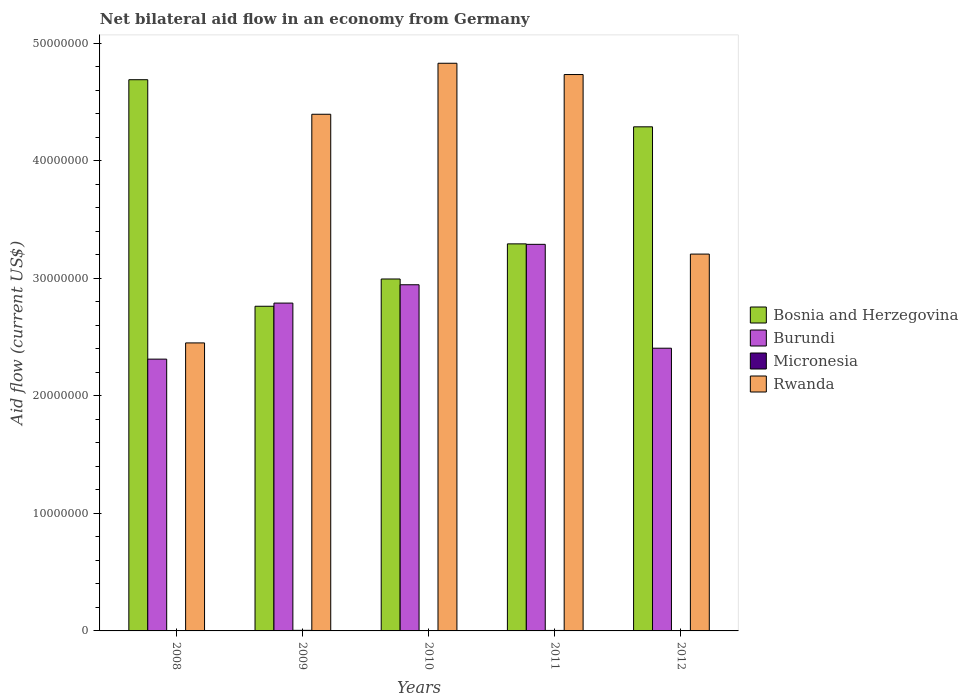How many different coloured bars are there?
Offer a very short reply. 4. Are the number of bars on each tick of the X-axis equal?
Make the answer very short. Yes. What is the net bilateral aid flow in Micronesia in 2008?
Give a very brief answer. 3.00e+04. Across all years, what is the maximum net bilateral aid flow in Burundi?
Provide a succinct answer. 3.29e+07. Across all years, what is the minimum net bilateral aid flow in Burundi?
Offer a very short reply. 2.31e+07. What is the total net bilateral aid flow in Burundi in the graph?
Provide a short and direct response. 1.37e+08. What is the difference between the net bilateral aid flow in Rwanda in 2008 and that in 2009?
Offer a terse response. -1.95e+07. What is the difference between the net bilateral aid flow in Rwanda in 2011 and the net bilateral aid flow in Bosnia and Herzegovina in 2012?
Your answer should be very brief. 4.45e+06. What is the average net bilateral aid flow in Burundi per year?
Provide a short and direct response. 2.75e+07. In the year 2009, what is the difference between the net bilateral aid flow in Micronesia and net bilateral aid flow in Rwanda?
Offer a very short reply. -4.39e+07. In how many years, is the net bilateral aid flow in Burundi greater than 42000000 US$?
Ensure brevity in your answer.  0. What is the ratio of the net bilateral aid flow in Burundi in 2009 to that in 2011?
Ensure brevity in your answer.  0.85. Is the difference between the net bilateral aid flow in Micronesia in 2011 and 2012 greater than the difference between the net bilateral aid flow in Rwanda in 2011 and 2012?
Provide a succinct answer. No. What is the difference between the highest and the second highest net bilateral aid flow in Bosnia and Herzegovina?
Offer a terse response. 4.01e+06. What is the difference between the highest and the lowest net bilateral aid flow in Bosnia and Herzegovina?
Offer a terse response. 1.93e+07. In how many years, is the net bilateral aid flow in Rwanda greater than the average net bilateral aid flow in Rwanda taken over all years?
Provide a succinct answer. 3. Is the sum of the net bilateral aid flow in Bosnia and Herzegovina in 2010 and 2011 greater than the maximum net bilateral aid flow in Micronesia across all years?
Make the answer very short. Yes. Is it the case that in every year, the sum of the net bilateral aid flow in Micronesia and net bilateral aid flow in Bosnia and Herzegovina is greater than the sum of net bilateral aid flow in Burundi and net bilateral aid flow in Rwanda?
Make the answer very short. No. What does the 2nd bar from the left in 2008 represents?
Provide a succinct answer. Burundi. What does the 1st bar from the right in 2012 represents?
Offer a terse response. Rwanda. How many years are there in the graph?
Give a very brief answer. 5. Where does the legend appear in the graph?
Your response must be concise. Center right. How many legend labels are there?
Your answer should be very brief. 4. What is the title of the graph?
Your answer should be compact. Net bilateral aid flow in an economy from Germany. What is the label or title of the X-axis?
Give a very brief answer. Years. What is the label or title of the Y-axis?
Offer a very short reply. Aid flow (current US$). What is the Aid flow (current US$) in Bosnia and Herzegovina in 2008?
Keep it short and to the point. 4.69e+07. What is the Aid flow (current US$) of Burundi in 2008?
Keep it short and to the point. 2.31e+07. What is the Aid flow (current US$) of Micronesia in 2008?
Your answer should be compact. 3.00e+04. What is the Aid flow (current US$) in Rwanda in 2008?
Your answer should be very brief. 2.45e+07. What is the Aid flow (current US$) of Bosnia and Herzegovina in 2009?
Your answer should be compact. 2.76e+07. What is the Aid flow (current US$) in Burundi in 2009?
Offer a terse response. 2.79e+07. What is the Aid flow (current US$) of Rwanda in 2009?
Your answer should be very brief. 4.40e+07. What is the Aid flow (current US$) of Bosnia and Herzegovina in 2010?
Your answer should be compact. 3.00e+07. What is the Aid flow (current US$) of Burundi in 2010?
Make the answer very short. 2.95e+07. What is the Aid flow (current US$) in Rwanda in 2010?
Offer a terse response. 4.83e+07. What is the Aid flow (current US$) in Bosnia and Herzegovina in 2011?
Offer a very short reply. 3.29e+07. What is the Aid flow (current US$) of Burundi in 2011?
Offer a very short reply. 3.29e+07. What is the Aid flow (current US$) of Rwanda in 2011?
Give a very brief answer. 4.74e+07. What is the Aid flow (current US$) of Bosnia and Herzegovina in 2012?
Offer a terse response. 4.29e+07. What is the Aid flow (current US$) of Burundi in 2012?
Provide a succinct answer. 2.41e+07. What is the Aid flow (current US$) of Rwanda in 2012?
Offer a terse response. 3.21e+07. Across all years, what is the maximum Aid flow (current US$) in Bosnia and Herzegovina?
Your answer should be very brief. 4.69e+07. Across all years, what is the maximum Aid flow (current US$) of Burundi?
Make the answer very short. 3.29e+07. Across all years, what is the maximum Aid flow (current US$) of Rwanda?
Provide a short and direct response. 4.83e+07. Across all years, what is the minimum Aid flow (current US$) in Bosnia and Herzegovina?
Your answer should be compact. 2.76e+07. Across all years, what is the minimum Aid flow (current US$) of Burundi?
Your answer should be very brief. 2.31e+07. Across all years, what is the minimum Aid flow (current US$) in Micronesia?
Your answer should be compact. 3.00e+04. Across all years, what is the minimum Aid flow (current US$) of Rwanda?
Your answer should be very brief. 2.45e+07. What is the total Aid flow (current US$) in Bosnia and Herzegovina in the graph?
Provide a succinct answer. 1.80e+08. What is the total Aid flow (current US$) of Burundi in the graph?
Your response must be concise. 1.37e+08. What is the total Aid flow (current US$) of Micronesia in the graph?
Provide a short and direct response. 1.80e+05. What is the total Aid flow (current US$) in Rwanda in the graph?
Your response must be concise. 1.96e+08. What is the difference between the Aid flow (current US$) of Bosnia and Herzegovina in 2008 and that in 2009?
Make the answer very short. 1.93e+07. What is the difference between the Aid flow (current US$) of Burundi in 2008 and that in 2009?
Your answer should be very brief. -4.77e+06. What is the difference between the Aid flow (current US$) of Rwanda in 2008 and that in 2009?
Make the answer very short. -1.95e+07. What is the difference between the Aid flow (current US$) in Bosnia and Herzegovina in 2008 and that in 2010?
Your answer should be compact. 1.70e+07. What is the difference between the Aid flow (current US$) in Burundi in 2008 and that in 2010?
Ensure brevity in your answer.  -6.33e+06. What is the difference between the Aid flow (current US$) of Micronesia in 2008 and that in 2010?
Your answer should be compact. 0. What is the difference between the Aid flow (current US$) of Rwanda in 2008 and that in 2010?
Your response must be concise. -2.38e+07. What is the difference between the Aid flow (current US$) in Bosnia and Herzegovina in 2008 and that in 2011?
Provide a succinct answer. 1.40e+07. What is the difference between the Aid flow (current US$) of Burundi in 2008 and that in 2011?
Your answer should be very brief. -9.77e+06. What is the difference between the Aid flow (current US$) of Micronesia in 2008 and that in 2011?
Provide a short and direct response. -10000. What is the difference between the Aid flow (current US$) in Rwanda in 2008 and that in 2011?
Make the answer very short. -2.28e+07. What is the difference between the Aid flow (current US$) in Bosnia and Herzegovina in 2008 and that in 2012?
Your response must be concise. 4.01e+06. What is the difference between the Aid flow (current US$) of Burundi in 2008 and that in 2012?
Keep it short and to the point. -9.30e+05. What is the difference between the Aid flow (current US$) in Rwanda in 2008 and that in 2012?
Give a very brief answer. -7.56e+06. What is the difference between the Aid flow (current US$) in Bosnia and Herzegovina in 2009 and that in 2010?
Your response must be concise. -2.32e+06. What is the difference between the Aid flow (current US$) in Burundi in 2009 and that in 2010?
Ensure brevity in your answer.  -1.56e+06. What is the difference between the Aid flow (current US$) in Rwanda in 2009 and that in 2010?
Provide a succinct answer. -4.34e+06. What is the difference between the Aid flow (current US$) of Bosnia and Herzegovina in 2009 and that in 2011?
Provide a succinct answer. -5.31e+06. What is the difference between the Aid flow (current US$) in Burundi in 2009 and that in 2011?
Offer a terse response. -5.00e+06. What is the difference between the Aid flow (current US$) of Rwanda in 2009 and that in 2011?
Your response must be concise. -3.38e+06. What is the difference between the Aid flow (current US$) of Bosnia and Herzegovina in 2009 and that in 2012?
Provide a succinct answer. -1.53e+07. What is the difference between the Aid flow (current US$) of Burundi in 2009 and that in 2012?
Keep it short and to the point. 3.84e+06. What is the difference between the Aid flow (current US$) in Micronesia in 2009 and that in 2012?
Ensure brevity in your answer.  2.00e+04. What is the difference between the Aid flow (current US$) in Rwanda in 2009 and that in 2012?
Provide a succinct answer. 1.19e+07. What is the difference between the Aid flow (current US$) of Bosnia and Herzegovina in 2010 and that in 2011?
Keep it short and to the point. -2.99e+06. What is the difference between the Aid flow (current US$) of Burundi in 2010 and that in 2011?
Provide a short and direct response. -3.44e+06. What is the difference between the Aid flow (current US$) of Micronesia in 2010 and that in 2011?
Offer a very short reply. -10000. What is the difference between the Aid flow (current US$) of Rwanda in 2010 and that in 2011?
Provide a succinct answer. 9.60e+05. What is the difference between the Aid flow (current US$) of Bosnia and Herzegovina in 2010 and that in 2012?
Your answer should be compact. -1.30e+07. What is the difference between the Aid flow (current US$) in Burundi in 2010 and that in 2012?
Ensure brevity in your answer.  5.40e+06. What is the difference between the Aid flow (current US$) in Micronesia in 2010 and that in 2012?
Your answer should be very brief. 0. What is the difference between the Aid flow (current US$) in Rwanda in 2010 and that in 2012?
Give a very brief answer. 1.62e+07. What is the difference between the Aid flow (current US$) in Bosnia and Herzegovina in 2011 and that in 2012?
Offer a very short reply. -9.96e+06. What is the difference between the Aid flow (current US$) of Burundi in 2011 and that in 2012?
Give a very brief answer. 8.84e+06. What is the difference between the Aid flow (current US$) of Micronesia in 2011 and that in 2012?
Provide a succinct answer. 10000. What is the difference between the Aid flow (current US$) of Rwanda in 2011 and that in 2012?
Offer a terse response. 1.53e+07. What is the difference between the Aid flow (current US$) in Bosnia and Herzegovina in 2008 and the Aid flow (current US$) in Burundi in 2009?
Keep it short and to the point. 1.90e+07. What is the difference between the Aid flow (current US$) of Bosnia and Herzegovina in 2008 and the Aid flow (current US$) of Micronesia in 2009?
Provide a short and direct response. 4.69e+07. What is the difference between the Aid flow (current US$) in Bosnia and Herzegovina in 2008 and the Aid flow (current US$) in Rwanda in 2009?
Provide a succinct answer. 2.94e+06. What is the difference between the Aid flow (current US$) of Burundi in 2008 and the Aid flow (current US$) of Micronesia in 2009?
Provide a short and direct response. 2.31e+07. What is the difference between the Aid flow (current US$) of Burundi in 2008 and the Aid flow (current US$) of Rwanda in 2009?
Provide a short and direct response. -2.08e+07. What is the difference between the Aid flow (current US$) in Micronesia in 2008 and the Aid flow (current US$) in Rwanda in 2009?
Ensure brevity in your answer.  -4.39e+07. What is the difference between the Aid flow (current US$) in Bosnia and Herzegovina in 2008 and the Aid flow (current US$) in Burundi in 2010?
Give a very brief answer. 1.74e+07. What is the difference between the Aid flow (current US$) in Bosnia and Herzegovina in 2008 and the Aid flow (current US$) in Micronesia in 2010?
Provide a short and direct response. 4.69e+07. What is the difference between the Aid flow (current US$) of Bosnia and Herzegovina in 2008 and the Aid flow (current US$) of Rwanda in 2010?
Provide a succinct answer. -1.40e+06. What is the difference between the Aid flow (current US$) of Burundi in 2008 and the Aid flow (current US$) of Micronesia in 2010?
Provide a succinct answer. 2.31e+07. What is the difference between the Aid flow (current US$) in Burundi in 2008 and the Aid flow (current US$) in Rwanda in 2010?
Provide a succinct answer. -2.52e+07. What is the difference between the Aid flow (current US$) of Micronesia in 2008 and the Aid flow (current US$) of Rwanda in 2010?
Provide a short and direct response. -4.83e+07. What is the difference between the Aid flow (current US$) in Bosnia and Herzegovina in 2008 and the Aid flow (current US$) in Burundi in 2011?
Give a very brief answer. 1.40e+07. What is the difference between the Aid flow (current US$) in Bosnia and Herzegovina in 2008 and the Aid flow (current US$) in Micronesia in 2011?
Provide a succinct answer. 4.69e+07. What is the difference between the Aid flow (current US$) of Bosnia and Herzegovina in 2008 and the Aid flow (current US$) of Rwanda in 2011?
Your response must be concise. -4.40e+05. What is the difference between the Aid flow (current US$) of Burundi in 2008 and the Aid flow (current US$) of Micronesia in 2011?
Your response must be concise. 2.31e+07. What is the difference between the Aid flow (current US$) in Burundi in 2008 and the Aid flow (current US$) in Rwanda in 2011?
Give a very brief answer. -2.42e+07. What is the difference between the Aid flow (current US$) of Micronesia in 2008 and the Aid flow (current US$) of Rwanda in 2011?
Provide a succinct answer. -4.73e+07. What is the difference between the Aid flow (current US$) of Bosnia and Herzegovina in 2008 and the Aid flow (current US$) of Burundi in 2012?
Provide a succinct answer. 2.28e+07. What is the difference between the Aid flow (current US$) in Bosnia and Herzegovina in 2008 and the Aid flow (current US$) in Micronesia in 2012?
Your response must be concise. 4.69e+07. What is the difference between the Aid flow (current US$) of Bosnia and Herzegovina in 2008 and the Aid flow (current US$) of Rwanda in 2012?
Offer a very short reply. 1.48e+07. What is the difference between the Aid flow (current US$) of Burundi in 2008 and the Aid flow (current US$) of Micronesia in 2012?
Provide a short and direct response. 2.31e+07. What is the difference between the Aid flow (current US$) of Burundi in 2008 and the Aid flow (current US$) of Rwanda in 2012?
Provide a succinct answer. -8.94e+06. What is the difference between the Aid flow (current US$) of Micronesia in 2008 and the Aid flow (current US$) of Rwanda in 2012?
Your response must be concise. -3.20e+07. What is the difference between the Aid flow (current US$) in Bosnia and Herzegovina in 2009 and the Aid flow (current US$) in Burundi in 2010?
Offer a very short reply. -1.83e+06. What is the difference between the Aid flow (current US$) of Bosnia and Herzegovina in 2009 and the Aid flow (current US$) of Micronesia in 2010?
Make the answer very short. 2.76e+07. What is the difference between the Aid flow (current US$) in Bosnia and Herzegovina in 2009 and the Aid flow (current US$) in Rwanda in 2010?
Provide a succinct answer. -2.07e+07. What is the difference between the Aid flow (current US$) in Burundi in 2009 and the Aid flow (current US$) in Micronesia in 2010?
Provide a succinct answer. 2.79e+07. What is the difference between the Aid flow (current US$) in Burundi in 2009 and the Aid flow (current US$) in Rwanda in 2010?
Your answer should be compact. -2.04e+07. What is the difference between the Aid flow (current US$) of Micronesia in 2009 and the Aid flow (current US$) of Rwanda in 2010?
Your answer should be compact. -4.83e+07. What is the difference between the Aid flow (current US$) of Bosnia and Herzegovina in 2009 and the Aid flow (current US$) of Burundi in 2011?
Your answer should be very brief. -5.27e+06. What is the difference between the Aid flow (current US$) in Bosnia and Herzegovina in 2009 and the Aid flow (current US$) in Micronesia in 2011?
Offer a very short reply. 2.76e+07. What is the difference between the Aid flow (current US$) in Bosnia and Herzegovina in 2009 and the Aid flow (current US$) in Rwanda in 2011?
Keep it short and to the point. -1.97e+07. What is the difference between the Aid flow (current US$) of Burundi in 2009 and the Aid flow (current US$) of Micronesia in 2011?
Your answer should be very brief. 2.79e+07. What is the difference between the Aid flow (current US$) of Burundi in 2009 and the Aid flow (current US$) of Rwanda in 2011?
Offer a very short reply. -1.94e+07. What is the difference between the Aid flow (current US$) in Micronesia in 2009 and the Aid flow (current US$) in Rwanda in 2011?
Your answer should be compact. -4.73e+07. What is the difference between the Aid flow (current US$) of Bosnia and Herzegovina in 2009 and the Aid flow (current US$) of Burundi in 2012?
Offer a terse response. 3.57e+06. What is the difference between the Aid flow (current US$) in Bosnia and Herzegovina in 2009 and the Aid flow (current US$) in Micronesia in 2012?
Offer a very short reply. 2.76e+07. What is the difference between the Aid flow (current US$) in Bosnia and Herzegovina in 2009 and the Aid flow (current US$) in Rwanda in 2012?
Make the answer very short. -4.44e+06. What is the difference between the Aid flow (current US$) in Burundi in 2009 and the Aid flow (current US$) in Micronesia in 2012?
Your answer should be very brief. 2.79e+07. What is the difference between the Aid flow (current US$) of Burundi in 2009 and the Aid flow (current US$) of Rwanda in 2012?
Provide a succinct answer. -4.17e+06. What is the difference between the Aid flow (current US$) of Micronesia in 2009 and the Aid flow (current US$) of Rwanda in 2012?
Keep it short and to the point. -3.20e+07. What is the difference between the Aid flow (current US$) of Bosnia and Herzegovina in 2010 and the Aid flow (current US$) of Burundi in 2011?
Your response must be concise. -2.95e+06. What is the difference between the Aid flow (current US$) in Bosnia and Herzegovina in 2010 and the Aid flow (current US$) in Micronesia in 2011?
Ensure brevity in your answer.  2.99e+07. What is the difference between the Aid flow (current US$) in Bosnia and Herzegovina in 2010 and the Aid flow (current US$) in Rwanda in 2011?
Offer a terse response. -1.74e+07. What is the difference between the Aid flow (current US$) in Burundi in 2010 and the Aid flow (current US$) in Micronesia in 2011?
Provide a succinct answer. 2.94e+07. What is the difference between the Aid flow (current US$) in Burundi in 2010 and the Aid flow (current US$) in Rwanda in 2011?
Keep it short and to the point. -1.79e+07. What is the difference between the Aid flow (current US$) in Micronesia in 2010 and the Aid flow (current US$) in Rwanda in 2011?
Provide a short and direct response. -4.73e+07. What is the difference between the Aid flow (current US$) of Bosnia and Herzegovina in 2010 and the Aid flow (current US$) of Burundi in 2012?
Provide a short and direct response. 5.89e+06. What is the difference between the Aid flow (current US$) in Bosnia and Herzegovina in 2010 and the Aid flow (current US$) in Micronesia in 2012?
Keep it short and to the point. 2.99e+07. What is the difference between the Aid flow (current US$) of Bosnia and Herzegovina in 2010 and the Aid flow (current US$) of Rwanda in 2012?
Offer a very short reply. -2.12e+06. What is the difference between the Aid flow (current US$) in Burundi in 2010 and the Aid flow (current US$) in Micronesia in 2012?
Offer a terse response. 2.94e+07. What is the difference between the Aid flow (current US$) in Burundi in 2010 and the Aid flow (current US$) in Rwanda in 2012?
Your response must be concise. -2.61e+06. What is the difference between the Aid flow (current US$) in Micronesia in 2010 and the Aid flow (current US$) in Rwanda in 2012?
Make the answer very short. -3.20e+07. What is the difference between the Aid flow (current US$) in Bosnia and Herzegovina in 2011 and the Aid flow (current US$) in Burundi in 2012?
Your response must be concise. 8.88e+06. What is the difference between the Aid flow (current US$) in Bosnia and Herzegovina in 2011 and the Aid flow (current US$) in Micronesia in 2012?
Provide a short and direct response. 3.29e+07. What is the difference between the Aid flow (current US$) in Bosnia and Herzegovina in 2011 and the Aid flow (current US$) in Rwanda in 2012?
Offer a terse response. 8.70e+05. What is the difference between the Aid flow (current US$) of Burundi in 2011 and the Aid flow (current US$) of Micronesia in 2012?
Your response must be concise. 3.29e+07. What is the difference between the Aid flow (current US$) of Burundi in 2011 and the Aid flow (current US$) of Rwanda in 2012?
Offer a very short reply. 8.30e+05. What is the difference between the Aid flow (current US$) of Micronesia in 2011 and the Aid flow (current US$) of Rwanda in 2012?
Provide a short and direct response. -3.20e+07. What is the average Aid flow (current US$) in Bosnia and Herzegovina per year?
Keep it short and to the point. 3.61e+07. What is the average Aid flow (current US$) of Burundi per year?
Ensure brevity in your answer.  2.75e+07. What is the average Aid flow (current US$) in Micronesia per year?
Give a very brief answer. 3.60e+04. What is the average Aid flow (current US$) in Rwanda per year?
Your answer should be very brief. 3.92e+07. In the year 2008, what is the difference between the Aid flow (current US$) of Bosnia and Herzegovina and Aid flow (current US$) of Burundi?
Your answer should be compact. 2.38e+07. In the year 2008, what is the difference between the Aid flow (current US$) of Bosnia and Herzegovina and Aid flow (current US$) of Micronesia?
Provide a succinct answer. 4.69e+07. In the year 2008, what is the difference between the Aid flow (current US$) in Bosnia and Herzegovina and Aid flow (current US$) in Rwanda?
Make the answer very short. 2.24e+07. In the year 2008, what is the difference between the Aid flow (current US$) in Burundi and Aid flow (current US$) in Micronesia?
Your answer should be very brief. 2.31e+07. In the year 2008, what is the difference between the Aid flow (current US$) of Burundi and Aid flow (current US$) of Rwanda?
Your response must be concise. -1.38e+06. In the year 2008, what is the difference between the Aid flow (current US$) in Micronesia and Aid flow (current US$) in Rwanda?
Provide a succinct answer. -2.45e+07. In the year 2009, what is the difference between the Aid flow (current US$) of Bosnia and Herzegovina and Aid flow (current US$) of Burundi?
Offer a very short reply. -2.70e+05. In the year 2009, what is the difference between the Aid flow (current US$) of Bosnia and Herzegovina and Aid flow (current US$) of Micronesia?
Your response must be concise. 2.76e+07. In the year 2009, what is the difference between the Aid flow (current US$) of Bosnia and Herzegovina and Aid flow (current US$) of Rwanda?
Your answer should be very brief. -1.63e+07. In the year 2009, what is the difference between the Aid flow (current US$) in Burundi and Aid flow (current US$) in Micronesia?
Your answer should be compact. 2.78e+07. In the year 2009, what is the difference between the Aid flow (current US$) in Burundi and Aid flow (current US$) in Rwanda?
Ensure brevity in your answer.  -1.61e+07. In the year 2009, what is the difference between the Aid flow (current US$) of Micronesia and Aid flow (current US$) of Rwanda?
Provide a succinct answer. -4.39e+07. In the year 2010, what is the difference between the Aid flow (current US$) in Bosnia and Herzegovina and Aid flow (current US$) in Burundi?
Provide a short and direct response. 4.90e+05. In the year 2010, what is the difference between the Aid flow (current US$) of Bosnia and Herzegovina and Aid flow (current US$) of Micronesia?
Keep it short and to the point. 2.99e+07. In the year 2010, what is the difference between the Aid flow (current US$) of Bosnia and Herzegovina and Aid flow (current US$) of Rwanda?
Your answer should be very brief. -1.84e+07. In the year 2010, what is the difference between the Aid flow (current US$) in Burundi and Aid flow (current US$) in Micronesia?
Offer a very short reply. 2.94e+07. In the year 2010, what is the difference between the Aid flow (current US$) in Burundi and Aid flow (current US$) in Rwanda?
Your response must be concise. -1.88e+07. In the year 2010, what is the difference between the Aid flow (current US$) of Micronesia and Aid flow (current US$) of Rwanda?
Provide a succinct answer. -4.83e+07. In the year 2011, what is the difference between the Aid flow (current US$) of Bosnia and Herzegovina and Aid flow (current US$) of Micronesia?
Offer a very short reply. 3.29e+07. In the year 2011, what is the difference between the Aid flow (current US$) in Bosnia and Herzegovina and Aid flow (current US$) in Rwanda?
Make the answer very short. -1.44e+07. In the year 2011, what is the difference between the Aid flow (current US$) in Burundi and Aid flow (current US$) in Micronesia?
Offer a very short reply. 3.29e+07. In the year 2011, what is the difference between the Aid flow (current US$) in Burundi and Aid flow (current US$) in Rwanda?
Keep it short and to the point. -1.44e+07. In the year 2011, what is the difference between the Aid flow (current US$) in Micronesia and Aid flow (current US$) in Rwanda?
Provide a short and direct response. -4.73e+07. In the year 2012, what is the difference between the Aid flow (current US$) of Bosnia and Herzegovina and Aid flow (current US$) of Burundi?
Keep it short and to the point. 1.88e+07. In the year 2012, what is the difference between the Aid flow (current US$) in Bosnia and Herzegovina and Aid flow (current US$) in Micronesia?
Your response must be concise. 4.29e+07. In the year 2012, what is the difference between the Aid flow (current US$) in Bosnia and Herzegovina and Aid flow (current US$) in Rwanda?
Provide a succinct answer. 1.08e+07. In the year 2012, what is the difference between the Aid flow (current US$) of Burundi and Aid flow (current US$) of Micronesia?
Keep it short and to the point. 2.40e+07. In the year 2012, what is the difference between the Aid flow (current US$) of Burundi and Aid flow (current US$) of Rwanda?
Ensure brevity in your answer.  -8.01e+06. In the year 2012, what is the difference between the Aid flow (current US$) of Micronesia and Aid flow (current US$) of Rwanda?
Give a very brief answer. -3.20e+07. What is the ratio of the Aid flow (current US$) in Bosnia and Herzegovina in 2008 to that in 2009?
Provide a short and direct response. 1.7. What is the ratio of the Aid flow (current US$) in Burundi in 2008 to that in 2009?
Your answer should be compact. 0.83. What is the ratio of the Aid flow (current US$) in Micronesia in 2008 to that in 2009?
Offer a terse response. 0.6. What is the ratio of the Aid flow (current US$) in Rwanda in 2008 to that in 2009?
Your answer should be compact. 0.56. What is the ratio of the Aid flow (current US$) in Bosnia and Herzegovina in 2008 to that in 2010?
Your response must be concise. 1.57. What is the ratio of the Aid flow (current US$) of Burundi in 2008 to that in 2010?
Offer a very short reply. 0.79. What is the ratio of the Aid flow (current US$) in Rwanda in 2008 to that in 2010?
Ensure brevity in your answer.  0.51. What is the ratio of the Aid flow (current US$) in Bosnia and Herzegovina in 2008 to that in 2011?
Offer a very short reply. 1.42. What is the ratio of the Aid flow (current US$) of Burundi in 2008 to that in 2011?
Your answer should be very brief. 0.7. What is the ratio of the Aid flow (current US$) in Micronesia in 2008 to that in 2011?
Your answer should be very brief. 0.75. What is the ratio of the Aid flow (current US$) in Rwanda in 2008 to that in 2011?
Your answer should be very brief. 0.52. What is the ratio of the Aid flow (current US$) in Bosnia and Herzegovina in 2008 to that in 2012?
Provide a short and direct response. 1.09. What is the ratio of the Aid flow (current US$) in Burundi in 2008 to that in 2012?
Ensure brevity in your answer.  0.96. What is the ratio of the Aid flow (current US$) in Micronesia in 2008 to that in 2012?
Offer a very short reply. 1. What is the ratio of the Aid flow (current US$) of Rwanda in 2008 to that in 2012?
Offer a terse response. 0.76. What is the ratio of the Aid flow (current US$) in Bosnia and Herzegovina in 2009 to that in 2010?
Keep it short and to the point. 0.92. What is the ratio of the Aid flow (current US$) of Burundi in 2009 to that in 2010?
Give a very brief answer. 0.95. What is the ratio of the Aid flow (current US$) of Rwanda in 2009 to that in 2010?
Offer a terse response. 0.91. What is the ratio of the Aid flow (current US$) of Bosnia and Herzegovina in 2009 to that in 2011?
Provide a short and direct response. 0.84. What is the ratio of the Aid flow (current US$) in Burundi in 2009 to that in 2011?
Provide a succinct answer. 0.85. What is the ratio of the Aid flow (current US$) of Bosnia and Herzegovina in 2009 to that in 2012?
Your answer should be very brief. 0.64. What is the ratio of the Aid flow (current US$) of Burundi in 2009 to that in 2012?
Offer a very short reply. 1.16. What is the ratio of the Aid flow (current US$) of Micronesia in 2009 to that in 2012?
Ensure brevity in your answer.  1.67. What is the ratio of the Aid flow (current US$) of Rwanda in 2009 to that in 2012?
Make the answer very short. 1.37. What is the ratio of the Aid flow (current US$) of Bosnia and Herzegovina in 2010 to that in 2011?
Make the answer very short. 0.91. What is the ratio of the Aid flow (current US$) in Burundi in 2010 to that in 2011?
Offer a terse response. 0.9. What is the ratio of the Aid flow (current US$) of Micronesia in 2010 to that in 2011?
Offer a very short reply. 0.75. What is the ratio of the Aid flow (current US$) in Rwanda in 2010 to that in 2011?
Your answer should be compact. 1.02. What is the ratio of the Aid flow (current US$) of Bosnia and Herzegovina in 2010 to that in 2012?
Your response must be concise. 0.7. What is the ratio of the Aid flow (current US$) in Burundi in 2010 to that in 2012?
Keep it short and to the point. 1.22. What is the ratio of the Aid flow (current US$) in Rwanda in 2010 to that in 2012?
Offer a very short reply. 1.51. What is the ratio of the Aid flow (current US$) in Bosnia and Herzegovina in 2011 to that in 2012?
Offer a very short reply. 0.77. What is the ratio of the Aid flow (current US$) in Burundi in 2011 to that in 2012?
Keep it short and to the point. 1.37. What is the ratio of the Aid flow (current US$) of Micronesia in 2011 to that in 2012?
Make the answer very short. 1.33. What is the ratio of the Aid flow (current US$) of Rwanda in 2011 to that in 2012?
Provide a short and direct response. 1.48. What is the difference between the highest and the second highest Aid flow (current US$) in Bosnia and Herzegovina?
Ensure brevity in your answer.  4.01e+06. What is the difference between the highest and the second highest Aid flow (current US$) in Burundi?
Keep it short and to the point. 3.44e+06. What is the difference between the highest and the second highest Aid flow (current US$) of Micronesia?
Make the answer very short. 10000. What is the difference between the highest and the second highest Aid flow (current US$) of Rwanda?
Make the answer very short. 9.60e+05. What is the difference between the highest and the lowest Aid flow (current US$) in Bosnia and Herzegovina?
Keep it short and to the point. 1.93e+07. What is the difference between the highest and the lowest Aid flow (current US$) of Burundi?
Provide a short and direct response. 9.77e+06. What is the difference between the highest and the lowest Aid flow (current US$) in Rwanda?
Offer a very short reply. 2.38e+07. 